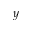Convert formula to latex. <formula><loc_0><loc_0><loc_500><loc_500>y</formula> 